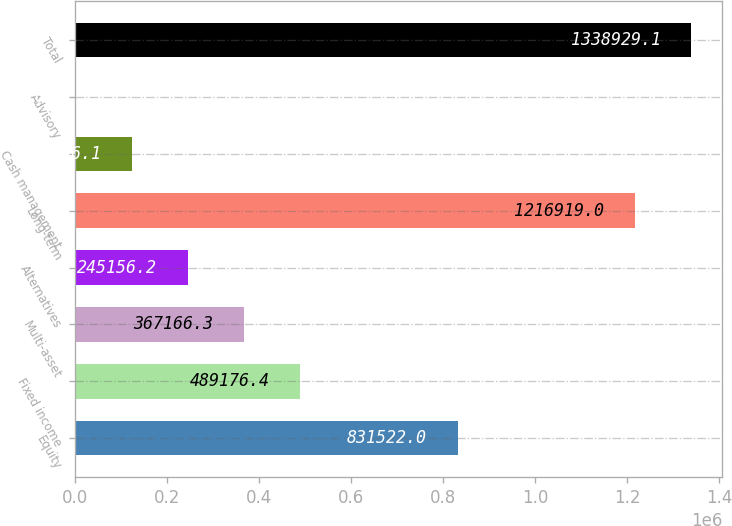Convert chart. <chart><loc_0><loc_0><loc_500><loc_500><bar_chart><fcel>Equity<fcel>Fixed income<fcel>Multi-asset<fcel>Alternatives<fcel>Long-term<fcel>Cash management<fcel>Advisory<fcel>Total<nl><fcel>831522<fcel>489176<fcel>367166<fcel>245156<fcel>1.21692e+06<fcel>123146<fcel>1136<fcel>1.33893e+06<nl></chart> 